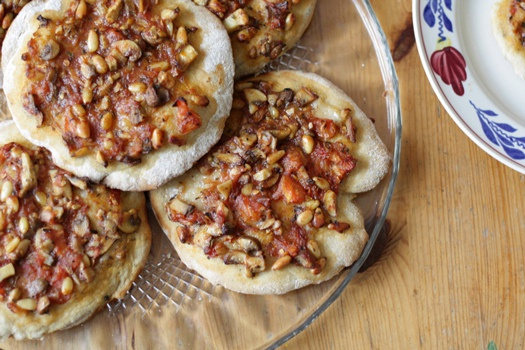Describe the objects in this image and their specific colors. I can see dining table in black, tan, lightgray, and gray tones, pizza in black, maroon, brown, gray, and tan tones, pizza in black, brown, lightgray, maroon, and gray tones, pizza in black, maroon, brown, gray, and tan tones, and pizza in black, maroon, and olive tones in this image. 